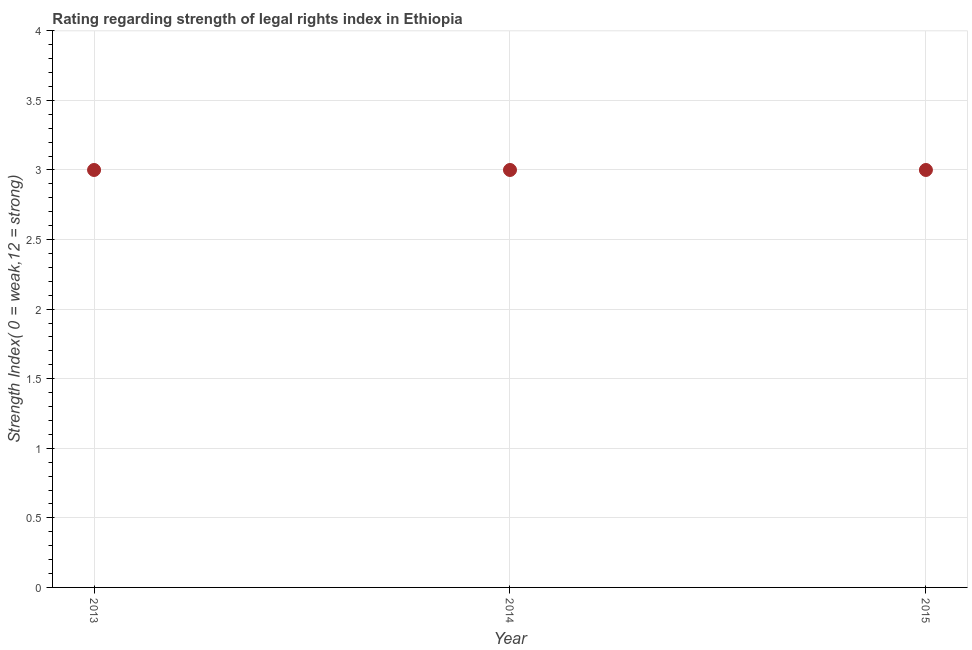What is the strength of legal rights index in 2014?
Your response must be concise. 3. Across all years, what is the maximum strength of legal rights index?
Make the answer very short. 3. Across all years, what is the minimum strength of legal rights index?
Your answer should be very brief. 3. What is the sum of the strength of legal rights index?
Keep it short and to the point. 9. What is the average strength of legal rights index per year?
Give a very brief answer. 3. What is the median strength of legal rights index?
Your answer should be compact. 3. In how many years, is the strength of legal rights index greater than 1.2 ?
Provide a succinct answer. 3. Do a majority of the years between 2015 and 2013 (inclusive) have strength of legal rights index greater than 1.7 ?
Make the answer very short. No. Is the sum of the strength of legal rights index in 2014 and 2015 greater than the maximum strength of legal rights index across all years?
Give a very brief answer. Yes. How many dotlines are there?
Ensure brevity in your answer.  1. How many years are there in the graph?
Offer a terse response. 3. Are the values on the major ticks of Y-axis written in scientific E-notation?
Give a very brief answer. No. What is the title of the graph?
Offer a terse response. Rating regarding strength of legal rights index in Ethiopia. What is the label or title of the Y-axis?
Offer a very short reply. Strength Index( 0 = weak,12 = strong). What is the Strength Index( 0 = weak,12 = strong) in 2014?
Offer a terse response. 3. What is the difference between the Strength Index( 0 = weak,12 = strong) in 2013 and 2015?
Your response must be concise. 0. What is the difference between the Strength Index( 0 = weak,12 = strong) in 2014 and 2015?
Offer a terse response. 0. What is the ratio of the Strength Index( 0 = weak,12 = strong) in 2014 to that in 2015?
Your answer should be compact. 1. 